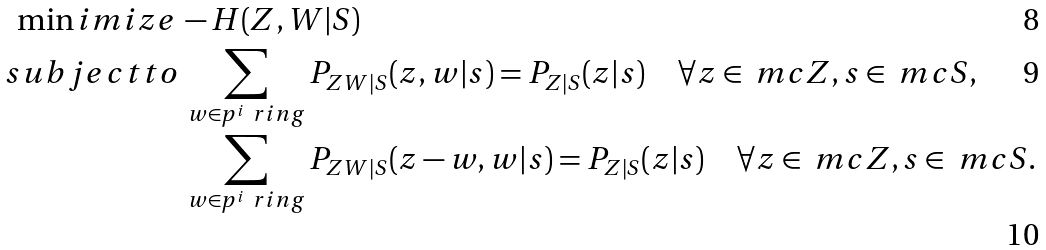Convert formula to latex. <formula><loc_0><loc_0><loc_500><loc_500>\min i m i z e \, & - H ( Z , W | S ) \\ s u b j e c t t o & \, \sum _ { w \in p ^ { i } \ r i n g } P _ { Z W | S } ( z , w | s ) = P _ { Z | S } ( z | s ) \quad \forall z \in \ m c { Z } , s \in \ m c { S } , \\ & \, \sum _ { w \in p ^ { i } \ r i n g } P _ { Z W | S } ( z - w , w | s ) = P _ { Z | S } ( z | s ) \quad \forall z \in \ m c { Z } , s \in \ m c { S } .</formula> 